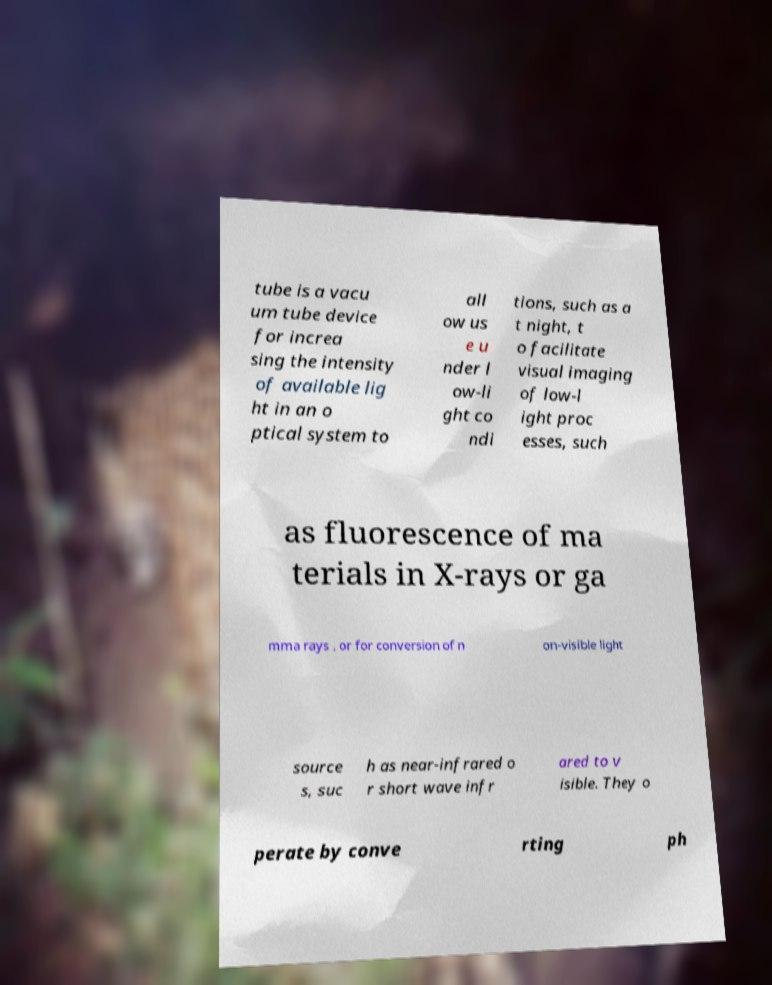Can you accurately transcribe the text from the provided image for me? tube is a vacu um tube device for increa sing the intensity of available lig ht in an o ptical system to all ow us e u nder l ow-li ght co ndi tions, such as a t night, t o facilitate visual imaging of low-l ight proc esses, such as fluorescence of ma terials in X-rays or ga mma rays , or for conversion of n on-visible light source s, suc h as near-infrared o r short wave infr ared to v isible. They o perate by conve rting ph 